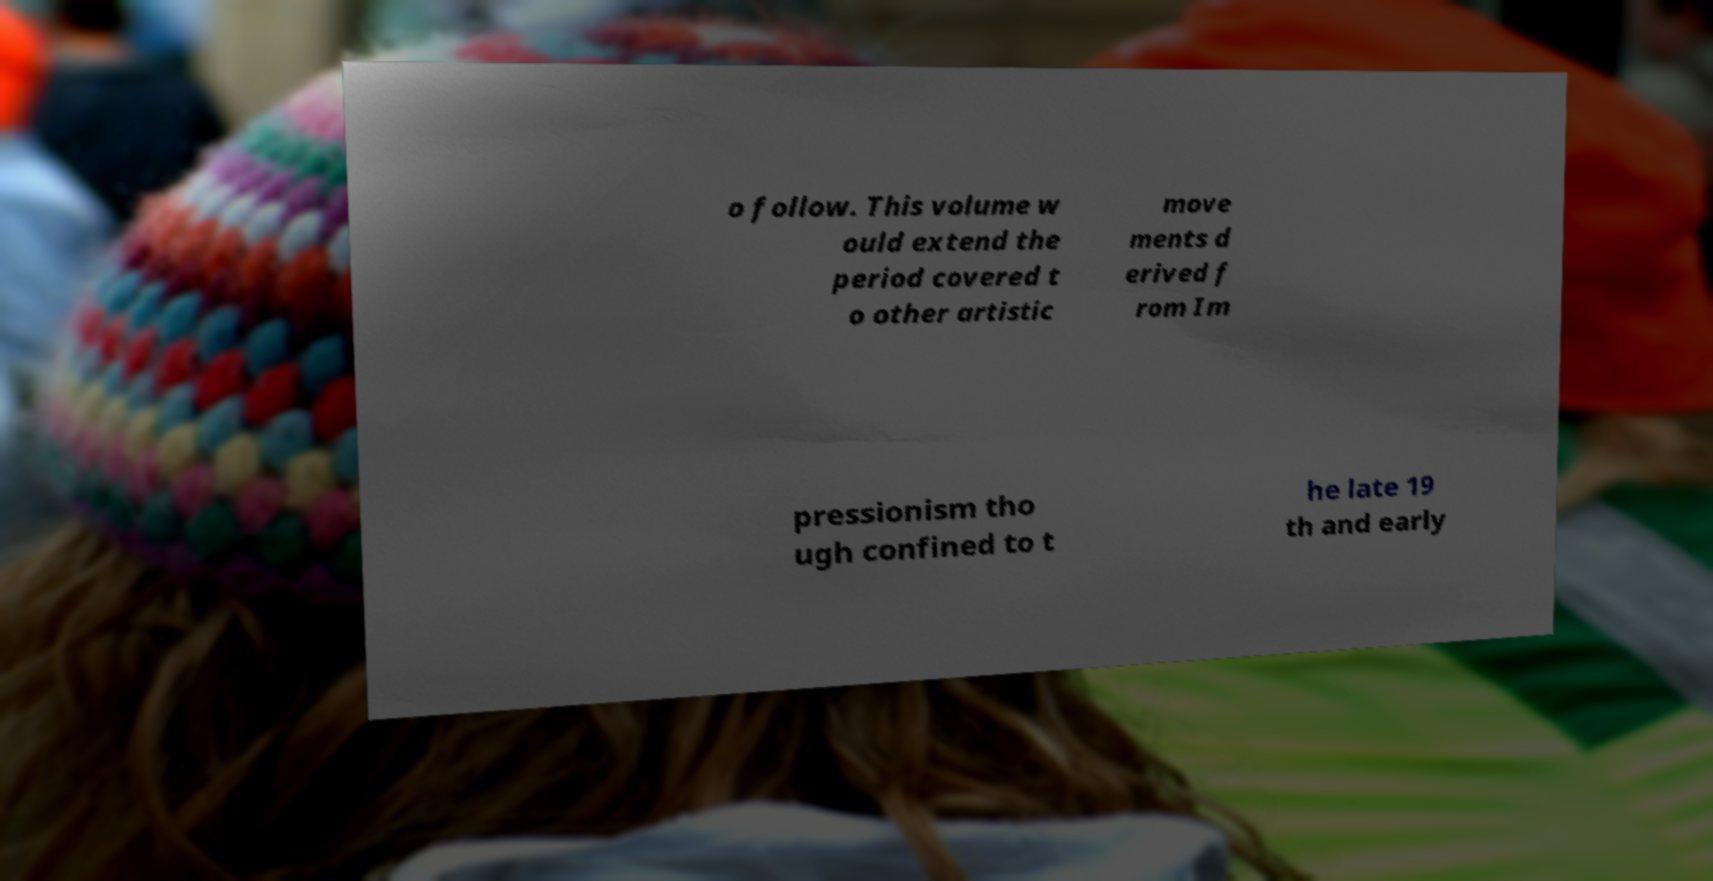Can you accurately transcribe the text from the provided image for me? o follow. This volume w ould extend the period covered t o other artistic move ments d erived f rom Im pressionism tho ugh confined to t he late 19 th and early 